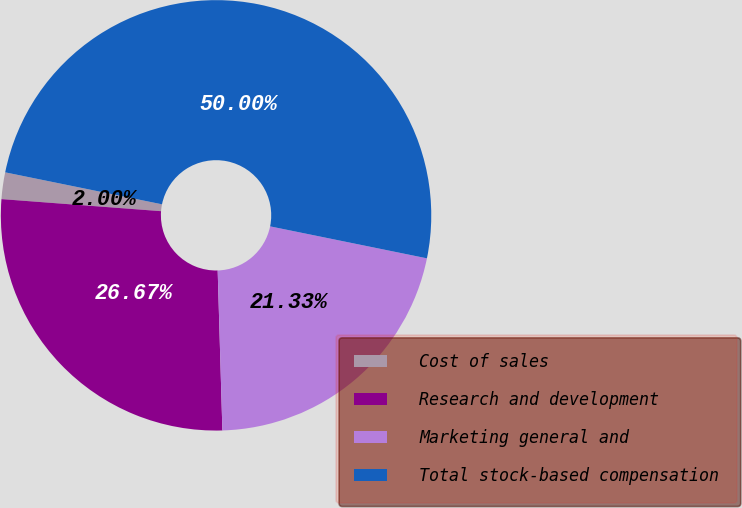Convert chart. <chart><loc_0><loc_0><loc_500><loc_500><pie_chart><fcel>Cost of sales<fcel>Research and development<fcel>Marketing general and<fcel>Total stock-based compensation<nl><fcel>2.0%<fcel>26.67%<fcel>21.33%<fcel>50.0%<nl></chart> 